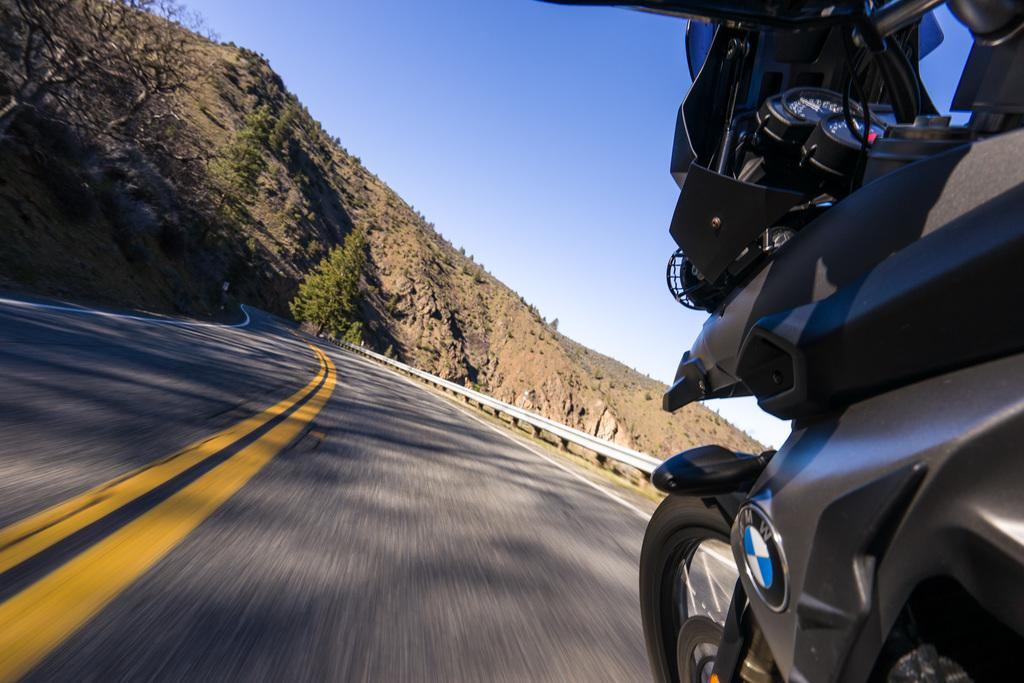What is the main object in the image? There is a bike in the image. What is the setting of the image? There is a road, trees, and a mountain in the image. What color is the sky in the image? The sky is blue at the top of the image. Where is the map located in the image? There is no map present in the image. What type of bait is being used by the bike in the image? The bike is not using any bait in the image, as it is an inanimate object. 